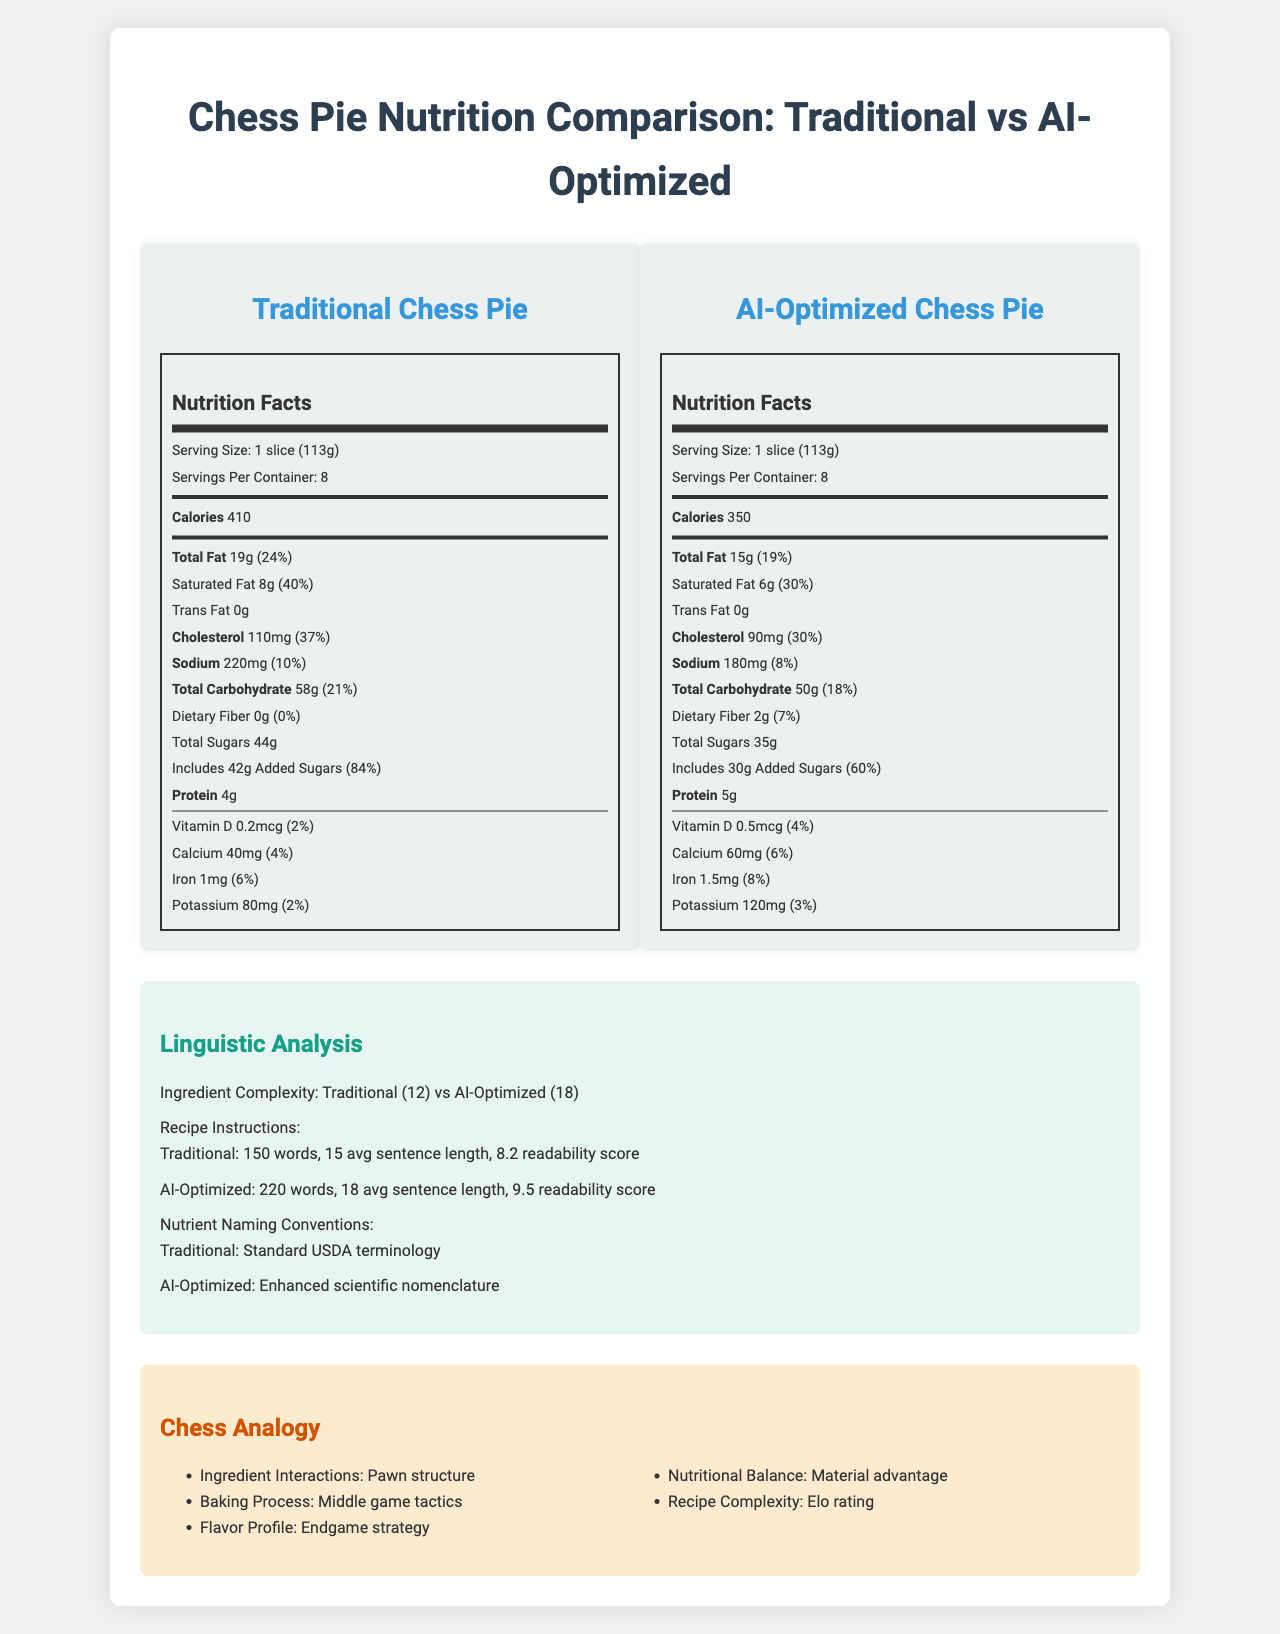what is the serving size for the traditional chess pie? The document states that the serving size for the traditional chess pie is 1 slice (113g).
Answer: 1 slice (113g) how many calories does the AI-optimized chess pie have per serving? The document indicates that the AI-optimized chess pie contains 350 calories per serving.
Answer: 350 calories what is the total fat content of the traditional chess pie? The document lists that the total fat content for the traditional chess pie is 19 grams.
Answer: 19g what is the sodium daily value percentage for the AI-optimized chess pie? The document specifies that the sodium content for the AI-optimized chess pie is 180mg, which is 8% of the daily value.
Answer: 8% how much dietary fiber is in the AI-optimized chess pie? The document shows that the AI-optimized chess pie contains 2 grams of dietary fiber.
Answer: 2g what is the difference in shelf life between the traditional and AI-optimized chess pies? The document indicates that the shelf life prediction for the traditional chess pie is 5 days, while for the AI-optimized chess pie it is 7 days.
Answer: 2 days what is the readability score of the AI-optimized recipe instructions? The document mentions that the readability score for the AI-optimized recipe instructions is 9.5.
Answer: 9.5 which pie has a higher nutritional balance score? A. Traditional Chess Pie B. AI-Optimized Chess Pie According to the document, the nutritional balance score for the traditional chess pie is 6.5, whereas for the AI-optimized chess pie it is 8.2.
Answer: B what is the average sentence length in the traditional recipe instructions? A. 10 words B. 12 words C. 15 words The document says the average sentence length in the traditional recipe instructions is 15 words.
Answer: C which ingredient complexity score is higher? A. Traditional Chess Pie B. AI-Optimized Chess Pie The document lists the ingredient complexity as 12 for the traditional chess pie and 18 for the AI-optimized chess pie.
Answer: B does the AI-optimized chess pie have any trans fat? The document states that the AI-optimized chess pie has 0 grams of trans fat.
Answer: No how are the ingredient interactions compared in the chess analogy? The document uses the chess analogy to compare ingredient interactions to a "pawn structure."
Answer: Pawn structure what are the values of the clustering coefficient for the ingredient word embeddings for both pies? The document lists the clustering coefficient for ingredient word embeddings as 0.65 for traditional and 0.72 for AI-optimized.
Answer: Traditional: 0.65, AI-Optimized: 0.72 what are the key sections of the document? The document is divided into key sections including Nutrition Facts for both pies, Linguistic Analysis, and Chess Analogy.
Answer: Nutrition Facts, Linguistic Analysis, Chess Analogy which pie has higher sodium content? The traditional chess pie has higher sodium content with 220mg compared to the AI-optimized chess pie with 180mg.
Answer: Traditional Chess Pie what ingredient interactions correspond to the chess analogy of the middle game tactics? According to the chess analogy section, the baking process corresponds to middle game tactics.
Answer: Baking process how many words are in the AI-optimized recipe instructions? The document states that the AI-optimized recipe instructions contain 220 words.
Answer: 220 words cannot find the name of the chef who developed the traditional chess pie The document does not provide any information about the name of the chef who developed the traditional chess pie.
Answer: Cannot be determined 